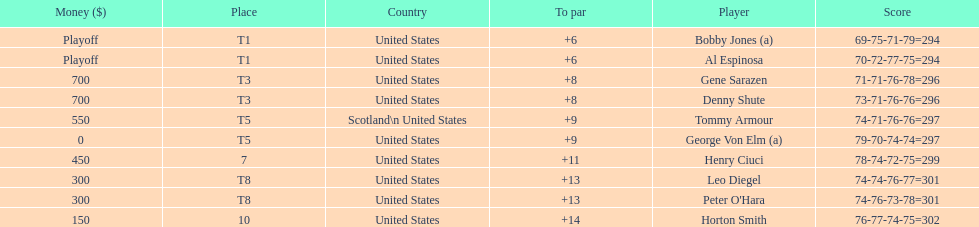Which two players tied for first place? Bobby Jones (a), Al Espinosa. 